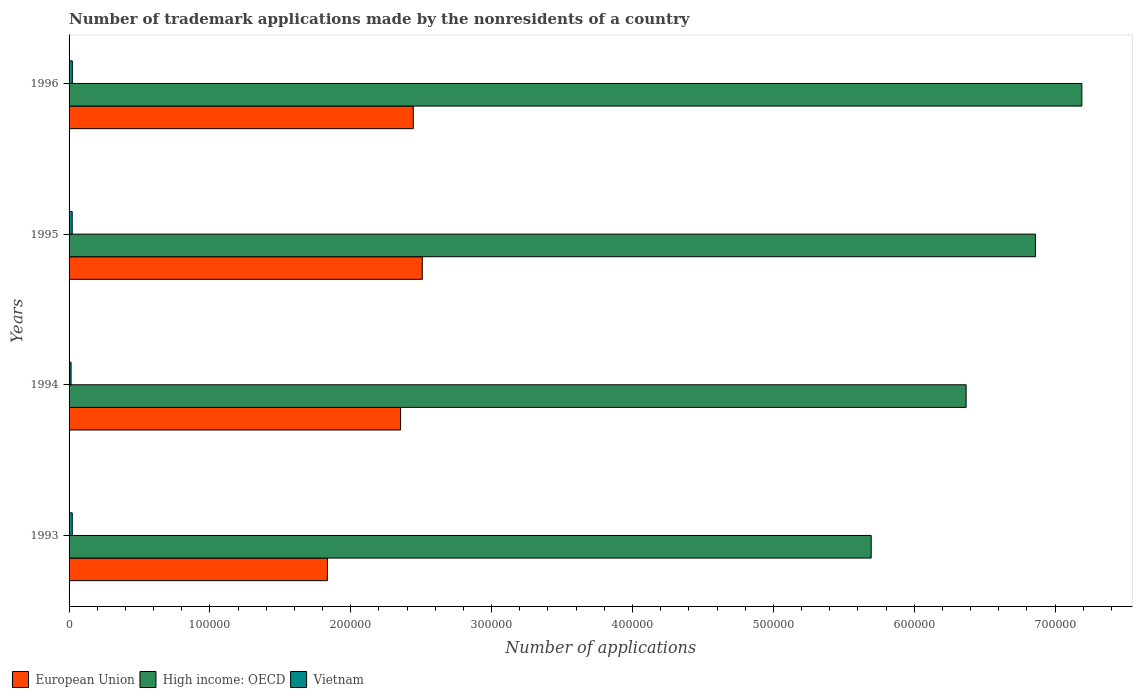Are the number of bars per tick equal to the number of legend labels?
Ensure brevity in your answer.  Yes. Are the number of bars on each tick of the Y-axis equal?
Offer a terse response. Yes. How many bars are there on the 2nd tick from the bottom?
Provide a succinct answer. 3. What is the label of the 3rd group of bars from the top?
Offer a very short reply. 1994. What is the number of trademark applications made by the nonresidents in Vietnam in 1993?
Provide a succinct answer. 2270. Across all years, what is the maximum number of trademark applications made by the nonresidents in European Union?
Keep it short and to the point. 2.51e+05. Across all years, what is the minimum number of trademark applications made by the nonresidents in Vietnam?
Your answer should be very brief. 1419. What is the total number of trademark applications made by the nonresidents in Vietnam in the graph?
Keep it short and to the point. 8229. What is the difference between the number of trademark applications made by the nonresidents in Vietnam in 1994 and that in 1995?
Offer a very short reply. -798. What is the difference between the number of trademark applications made by the nonresidents in European Union in 1993 and the number of trademark applications made by the nonresidents in Vietnam in 1994?
Ensure brevity in your answer.  1.82e+05. What is the average number of trademark applications made by the nonresidents in Vietnam per year?
Your answer should be compact. 2057.25. In the year 1995, what is the difference between the number of trademark applications made by the nonresidents in High income: OECD and number of trademark applications made by the nonresidents in Vietnam?
Your answer should be compact. 6.84e+05. What is the ratio of the number of trademark applications made by the nonresidents in European Union in 1993 to that in 1996?
Give a very brief answer. 0.75. What is the difference between the highest and the second highest number of trademark applications made by the nonresidents in European Union?
Your answer should be very brief. 6398. What is the difference between the highest and the lowest number of trademark applications made by the nonresidents in High income: OECD?
Give a very brief answer. 1.50e+05. In how many years, is the number of trademark applications made by the nonresidents in European Union greater than the average number of trademark applications made by the nonresidents in European Union taken over all years?
Give a very brief answer. 3. Is the sum of the number of trademark applications made by the nonresidents in European Union in 1993 and 1995 greater than the maximum number of trademark applications made by the nonresidents in Vietnam across all years?
Offer a terse response. Yes. What does the 1st bar from the top in 1994 represents?
Keep it short and to the point. Vietnam. What does the 2nd bar from the bottom in 1996 represents?
Your response must be concise. High income: OECD. Is it the case that in every year, the sum of the number of trademark applications made by the nonresidents in European Union and number of trademark applications made by the nonresidents in Vietnam is greater than the number of trademark applications made by the nonresidents in High income: OECD?
Offer a very short reply. No. How many bars are there?
Give a very brief answer. 12. Are all the bars in the graph horizontal?
Provide a short and direct response. Yes. How many years are there in the graph?
Provide a short and direct response. 4. Does the graph contain any zero values?
Your response must be concise. No. Does the graph contain grids?
Offer a very short reply. No. What is the title of the graph?
Make the answer very short. Number of trademark applications made by the nonresidents of a country. Does "Iraq" appear as one of the legend labels in the graph?
Keep it short and to the point. No. What is the label or title of the X-axis?
Provide a succinct answer. Number of applications. What is the label or title of the Y-axis?
Make the answer very short. Years. What is the Number of applications of European Union in 1993?
Your response must be concise. 1.83e+05. What is the Number of applications in High income: OECD in 1993?
Your response must be concise. 5.69e+05. What is the Number of applications of Vietnam in 1993?
Provide a short and direct response. 2270. What is the Number of applications in European Union in 1994?
Provide a short and direct response. 2.35e+05. What is the Number of applications in High income: OECD in 1994?
Offer a terse response. 6.37e+05. What is the Number of applications of Vietnam in 1994?
Provide a succinct answer. 1419. What is the Number of applications in European Union in 1995?
Provide a short and direct response. 2.51e+05. What is the Number of applications of High income: OECD in 1995?
Offer a very short reply. 6.86e+05. What is the Number of applications in Vietnam in 1995?
Provide a succinct answer. 2217. What is the Number of applications in European Union in 1996?
Your answer should be compact. 2.44e+05. What is the Number of applications of High income: OECD in 1996?
Your response must be concise. 7.19e+05. What is the Number of applications of Vietnam in 1996?
Offer a terse response. 2323. Across all years, what is the maximum Number of applications of European Union?
Provide a succinct answer. 2.51e+05. Across all years, what is the maximum Number of applications of High income: OECD?
Provide a succinct answer. 7.19e+05. Across all years, what is the maximum Number of applications in Vietnam?
Provide a short and direct response. 2323. Across all years, what is the minimum Number of applications of European Union?
Your response must be concise. 1.83e+05. Across all years, what is the minimum Number of applications in High income: OECD?
Your answer should be very brief. 5.69e+05. Across all years, what is the minimum Number of applications of Vietnam?
Give a very brief answer. 1419. What is the total Number of applications in European Union in the graph?
Offer a very short reply. 9.14e+05. What is the total Number of applications in High income: OECD in the graph?
Offer a very short reply. 2.61e+06. What is the total Number of applications of Vietnam in the graph?
Offer a terse response. 8229. What is the difference between the Number of applications in European Union in 1993 and that in 1994?
Provide a succinct answer. -5.19e+04. What is the difference between the Number of applications of High income: OECD in 1993 and that in 1994?
Provide a succinct answer. -6.74e+04. What is the difference between the Number of applications of Vietnam in 1993 and that in 1994?
Provide a succinct answer. 851. What is the difference between the Number of applications of European Union in 1993 and that in 1995?
Offer a terse response. -6.73e+04. What is the difference between the Number of applications in High income: OECD in 1993 and that in 1995?
Your response must be concise. -1.17e+05. What is the difference between the Number of applications in European Union in 1993 and that in 1996?
Your answer should be very brief. -6.09e+04. What is the difference between the Number of applications of High income: OECD in 1993 and that in 1996?
Offer a terse response. -1.50e+05. What is the difference between the Number of applications of Vietnam in 1993 and that in 1996?
Offer a terse response. -53. What is the difference between the Number of applications of European Union in 1994 and that in 1995?
Make the answer very short. -1.54e+04. What is the difference between the Number of applications of High income: OECD in 1994 and that in 1995?
Make the answer very short. -4.92e+04. What is the difference between the Number of applications of Vietnam in 1994 and that in 1995?
Provide a succinct answer. -798. What is the difference between the Number of applications of European Union in 1994 and that in 1996?
Make the answer very short. -9007. What is the difference between the Number of applications of High income: OECD in 1994 and that in 1996?
Offer a very short reply. -8.22e+04. What is the difference between the Number of applications of Vietnam in 1994 and that in 1996?
Provide a short and direct response. -904. What is the difference between the Number of applications of European Union in 1995 and that in 1996?
Keep it short and to the point. 6398. What is the difference between the Number of applications of High income: OECD in 1995 and that in 1996?
Your answer should be compact. -3.30e+04. What is the difference between the Number of applications of Vietnam in 1995 and that in 1996?
Keep it short and to the point. -106. What is the difference between the Number of applications of European Union in 1993 and the Number of applications of High income: OECD in 1994?
Your response must be concise. -4.53e+05. What is the difference between the Number of applications in European Union in 1993 and the Number of applications in Vietnam in 1994?
Provide a short and direct response. 1.82e+05. What is the difference between the Number of applications in High income: OECD in 1993 and the Number of applications in Vietnam in 1994?
Your response must be concise. 5.68e+05. What is the difference between the Number of applications of European Union in 1993 and the Number of applications of High income: OECD in 1995?
Give a very brief answer. -5.03e+05. What is the difference between the Number of applications of European Union in 1993 and the Number of applications of Vietnam in 1995?
Keep it short and to the point. 1.81e+05. What is the difference between the Number of applications in High income: OECD in 1993 and the Number of applications in Vietnam in 1995?
Provide a short and direct response. 5.67e+05. What is the difference between the Number of applications in European Union in 1993 and the Number of applications in High income: OECD in 1996?
Provide a succinct answer. -5.36e+05. What is the difference between the Number of applications in European Union in 1993 and the Number of applications in Vietnam in 1996?
Give a very brief answer. 1.81e+05. What is the difference between the Number of applications of High income: OECD in 1993 and the Number of applications of Vietnam in 1996?
Make the answer very short. 5.67e+05. What is the difference between the Number of applications of European Union in 1994 and the Number of applications of High income: OECD in 1995?
Make the answer very short. -4.51e+05. What is the difference between the Number of applications of European Union in 1994 and the Number of applications of Vietnam in 1995?
Your response must be concise. 2.33e+05. What is the difference between the Number of applications of High income: OECD in 1994 and the Number of applications of Vietnam in 1995?
Your response must be concise. 6.35e+05. What is the difference between the Number of applications in European Union in 1994 and the Number of applications in High income: OECD in 1996?
Give a very brief answer. -4.84e+05. What is the difference between the Number of applications of European Union in 1994 and the Number of applications of Vietnam in 1996?
Your answer should be very brief. 2.33e+05. What is the difference between the Number of applications in High income: OECD in 1994 and the Number of applications in Vietnam in 1996?
Provide a short and direct response. 6.35e+05. What is the difference between the Number of applications in European Union in 1995 and the Number of applications in High income: OECD in 1996?
Make the answer very short. -4.68e+05. What is the difference between the Number of applications in European Union in 1995 and the Number of applications in Vietnam in 1996?
Give a very brief answer. 2.48e+05. What is the difference between the Number of applications of High income: OECD in 1995 and the Number of applications of Vietnam in 1996?
Keep it short and to the point. 6.84e+05. What is the average Number of applications in European Union per year?
Your answer should be compact. 2.28e+05. What is the average Number of applications in High income: OECD per year?
Offer a terse response. 6.53e+05. What is the average Number of applications of Vietnam per year?
Make the answer very short. 2057.25. In the year 1993, what is the difference between the Number of applications of European Union and Number of applications of High income: OECD?
Make the answer very short. -3.86e+05. In the year 1993, what is the difference between the Number of applications of European Union and Number of applications of Vietnam?
Offer a very short reply. 1.81e+05. In the year 1993, what is the difference between the Number of applications in High income: OECD and Number of applications in Vietnam?
Your answer should be very brief. 5.67e+05. In the year 1994, what is the difference between the Number of applications in European Union and Number of applications in High income: OECD?
Keep it short and to the point. -4.01e+05. In the year 1994, what is the difference between the Number of applications of European Union and Number of applications of Vietnam?
Your response must be concise. 2.34e+05. In the year 1994, what is the difference between the Number of applications in High income: OECD and Number of applications in Vietnam?
Give a very brief answer. 6.35e+05. In the year 1995, what is the difference between the Number of applications in European Union and Number of applications in High income: OECD?
Your answer should be compact. -4.35e+05. In the year 1995, what is the difference between the Number of applications in European Union and Number of applications in Vietnam?
Offer a terse response. 2.49e+05. In the year 1995, what is the difference between the Number of applications in High income: OECD and Number of applications in Vietnam?
Ensure brevity in your answer.  6.84e+05. In the year 1996, what is the difference between the Number of applications in European Union and Number of applications in High income: OECD?
Make the answer very short. -4.75e+05. In the year 1996, what is the difference between the Number of applications in European Union and Number of applications in Vietnam?
Your answer should be very brief. 2.42e+05. In the year 1996, what is the difference between the Number of applications of High income: OECD and Number of applications of Vietnam?
Provide a short and direct response. 7.17e+05. What is the ratio of the Number of applications of European Union in 1993 to that in 1994?
Keep it short and to the point. 0.78. What is the ratio of the Number of applications in High income: OECD in 1993 to that in 1994?
Your response must be concise. 0.89. What is the ratio of the Number of applications in Vietnam in 1993 to that in 1994?
Provide a short and direct response. 1.6. What is the ratio of the Number of applications in European Union in 1993 to that in 1995?
Ensure brevity in your answer.  0.73. What is the ratio of the Number of applications of High income: OECD in 1993 to that in 1995?
Provide a short and direct response. 0.83. What is the ratio of the Number of applications of Vietnam in 1993 to that in 1995?
Make the answer very short. 1.02. What is the ratio of the Number of applications of European Union in 1993 to that in 1996?
Make the answer very short. 0.75. What is the ratio of the Number of applications in High income: OECD in 1993 to that in 1996?
Offer a very short reply. 0.79. What is the ratio of the Number of applications of Vietnam in 1993 to that in 1996?
Your answer should be very brief. 0.98. What is the ratio of the Number of applications of European Union in 1994 to that in 1995?
Your response must be concise. 0.94. What is the ratio of the Number of applications of High income: OECD in 1994 to that in 1995?
Your answer should be very brief. 0.93. What is the ratio of the Number of applications of Vietnam in 1994 to that in 1995?
Your answer should be compact. 0.64. What is the ratio of the Number of applications in European Union in 1994 to that in 1996?
Provide a succinct answer. 0.96. What is the ratio of the Number of applications of High income: OECD in 1994 to that in 1996?
Offer a terse response. 0.89. What is the ratio of the Number of applications in Vietnam in 1994 to that in 1996?
Your response must be concise. 0.61. What is the ratio of the Number of applications of European Union in 1995 to that in 1996?
Provide a short and direct response. 1.03. What is the ratio of the Number of applications of High income: OECD in 1995 to that in 1996?
Give a very brief answer. 0.95. What is the ratio of the Number of applications of Vietnam in 1995 to that in 1996?
Ensure brevity in your answer.  0.95. What is the difference between the highest and the second highest Number of applications in European Union?
Keep it short and to the point. 6398. What is the difference between the highest and the second highest Number of applications in High income: OECD?
Provide a succinct answer. 3.30e+04. What is the difference between the highest and the second highest Number of applications of Vietnam?
Offer a very short reply. 53. What is the difference between the highest and the lowest Number of applications in European Union?
Ensure brevity in your answer.  6.73e+04. What is the difference between the highest and the lowest Number of applications in High income: OECD?
Keep it short and to the point. 1.50e+05. What is the difference between the highest and the lowest Number of applications of Vietnam?
Your answer should be very brief. 904. 